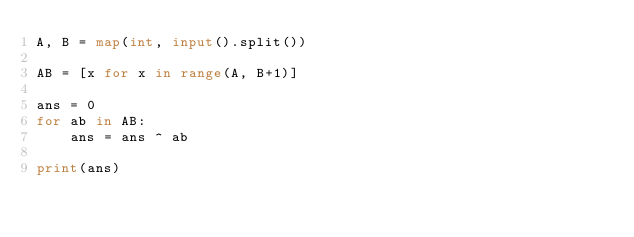<code> <loc_0><loc_0><loc_500><loc_500><_Python_>A, B = map(int, input().split())

AB = [x for x in range(A, B+1)]

ans = 0
for ab in AB:
    ans = ans ^ ab

print(ans)





</code> 